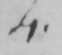What is written in this line of handwriting? 4 . 